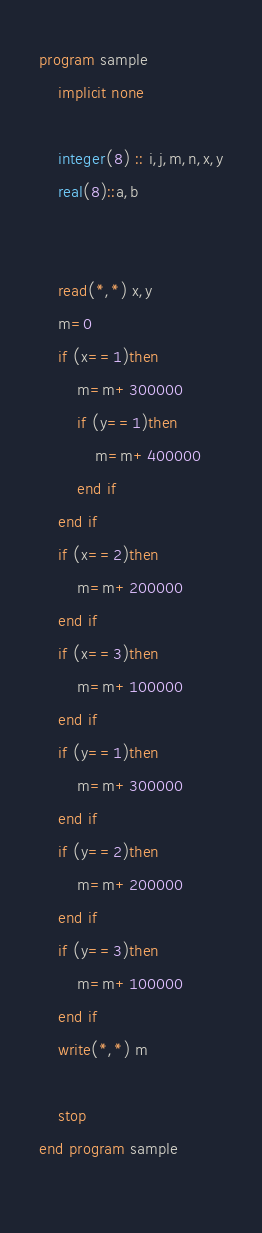<code> <loc_0><loc_0><loc_500><loc_500><_FORTRAN_>program sample
    implicit none
  
    integer(8) :: i,j,m,n,x,y
    real(8)::a,b
    
  
    read(*,*) x,y
    m=0
    if (x==1)then
        m=m+300000
        if (y==1)then
            m=m+400000
        end if
    end if
    if (x==2)then
        m=m+200000
    end if
    if (x==3)then
        m=m+100000
    end if
    if (y==1)then
        m=m+300000
    end if
    if (y==2)then
        m=m+200000
    end if
    if (y==3)then
        m=m+100000
    end if
    write(*,*) m
  
    stop
end program sample
  

</code> 